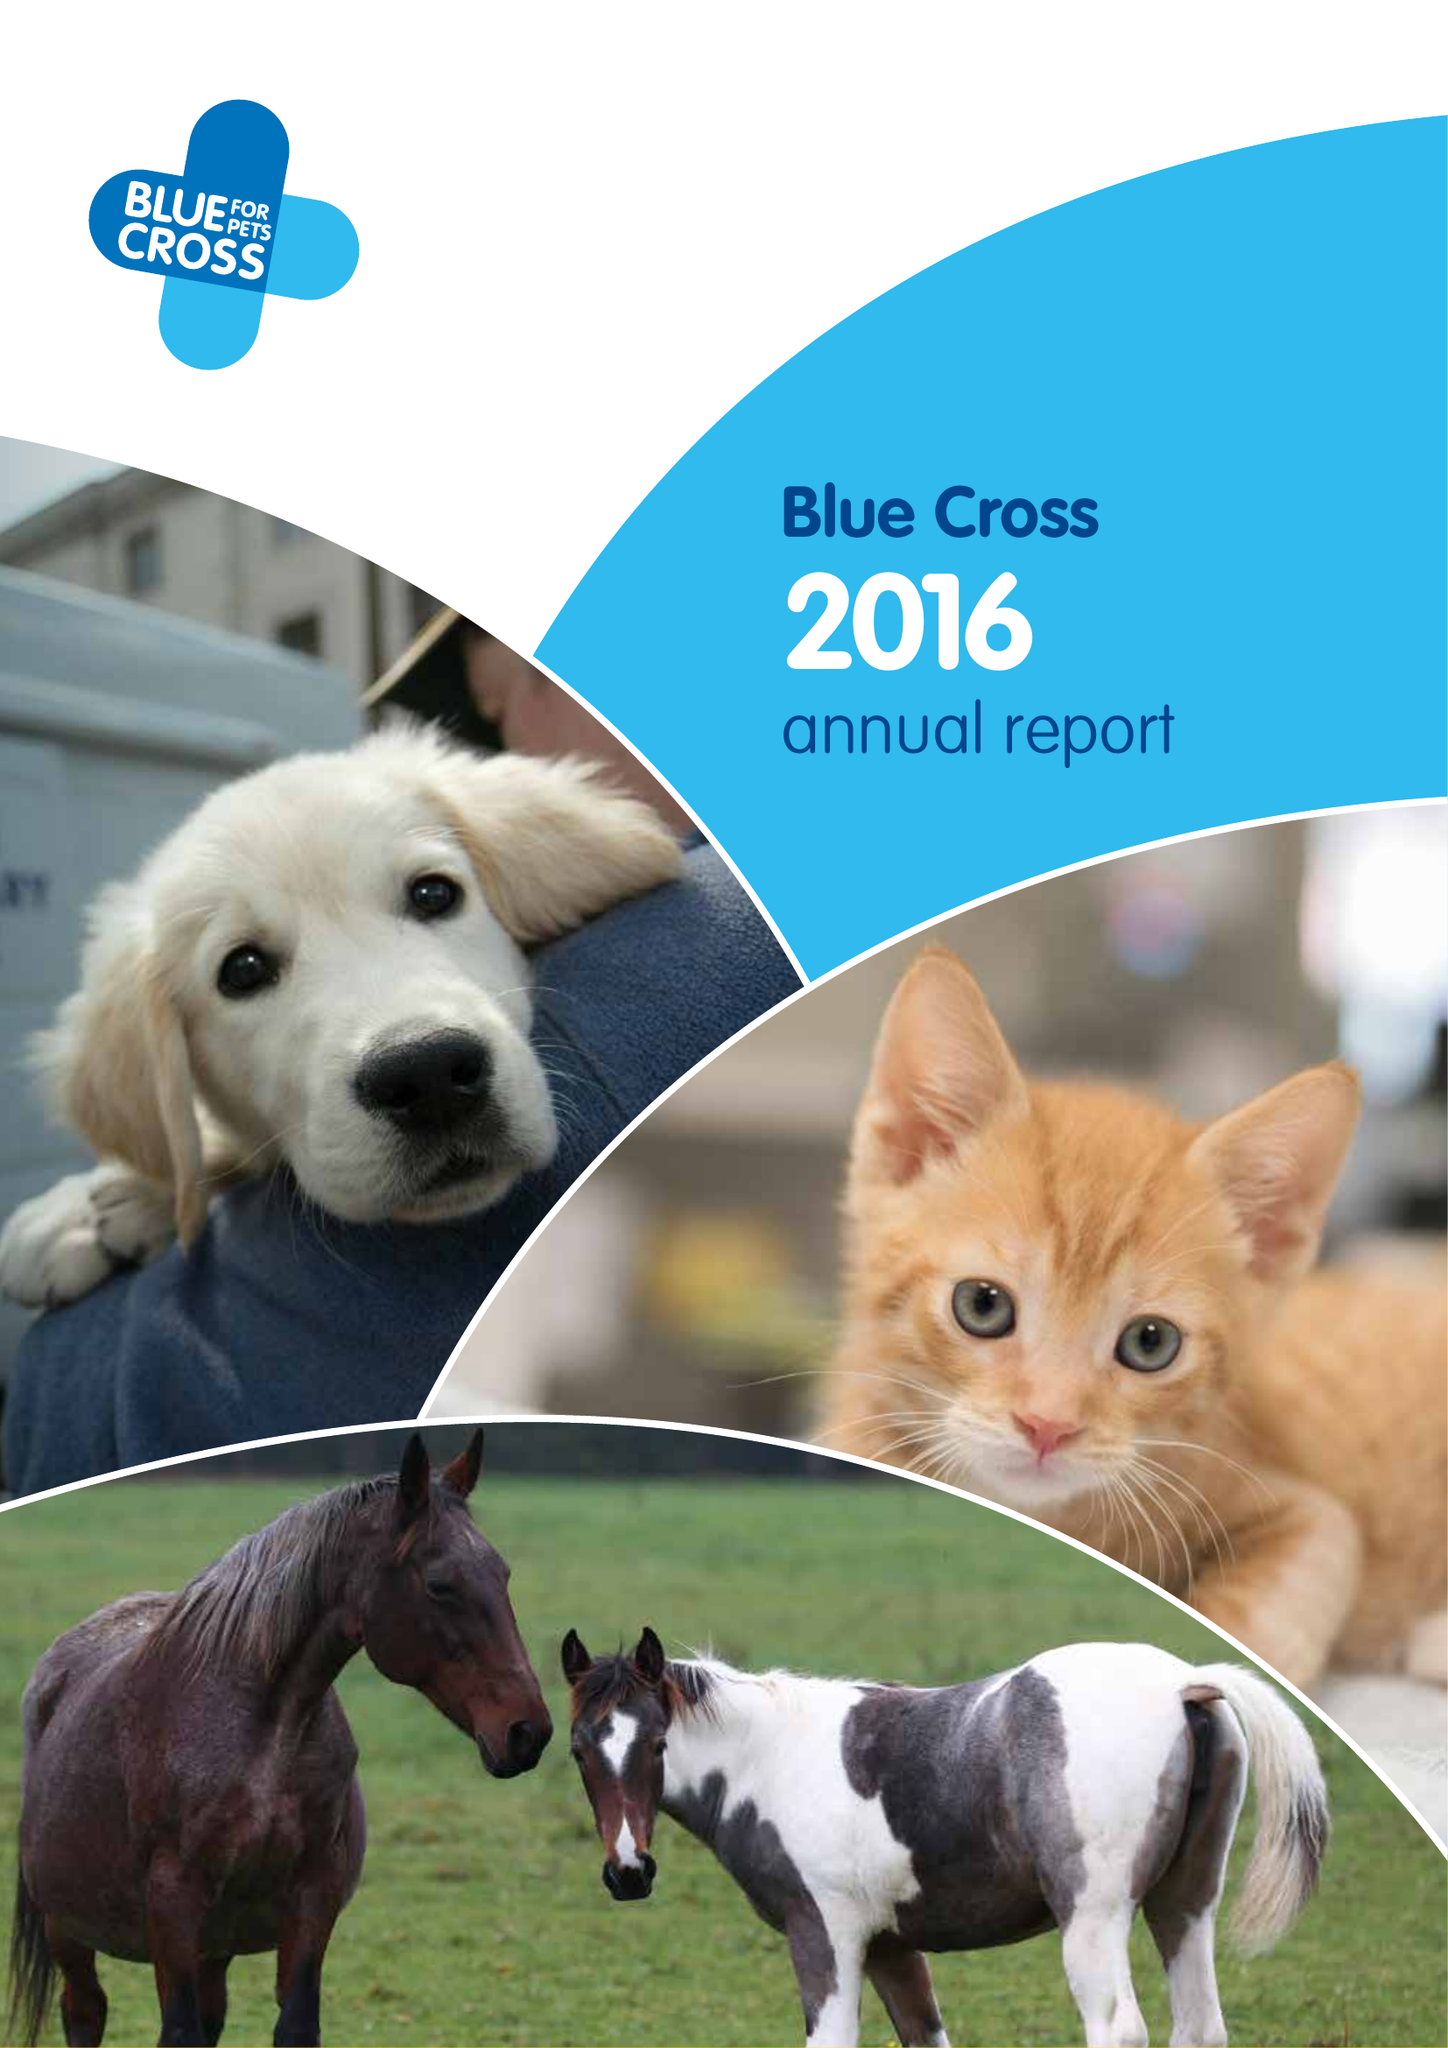What is the value for the charity_number?
Answer the question using a single word or phrase. 224392 